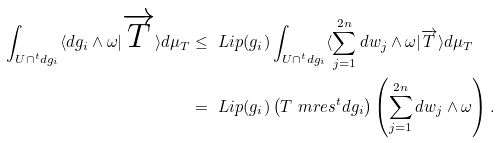Convert formula to latex. <formula><loc_0><loc_0><loc_500><loc_500>\int _ { U \cap ^ { t } d g _ { i } } \langle d g _ { i } \wedge \omega | \overrightarrow { T } \rangle d \mu _ { T } & \leq \ L i p ( g _ { i } ) \int _ { U \cap ^ { t } d g _ { i } } \langle \sum _ { j = 1 } ^ { 2 n } d w _ { j } \wedge \omega | \overrightarrow { T } \rangle d \mu _ { T } \\ & = \ L i p ( g _ { i } ) \left ( T \ m r e s ^ { t } d g _ { i } \right ) \left ( \sum _ { j = 1 } ^ { 2 n } d w _ { j } \wedge \omega \right ) .</formula> 